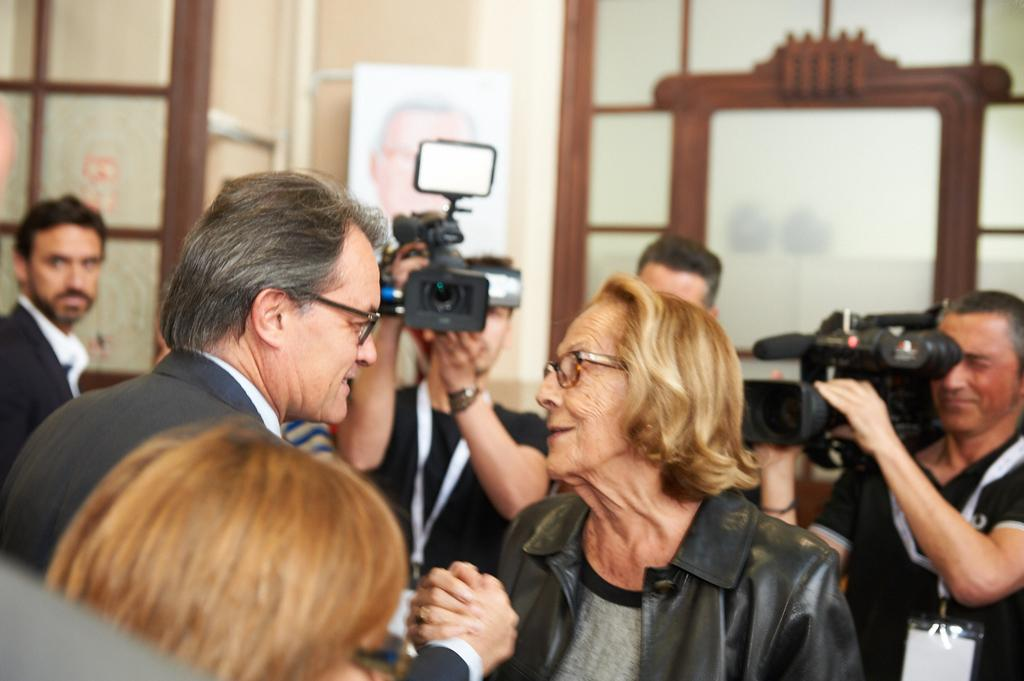How many people are present in the image? There are two people, a man and a woman, present in the image. What are the man and woman doing in the image? The man and woman are holding hands in the image. What can be seen in the background of the image? There are 2 cameramen and 2 men in the background of the image. What type of crown is the man wearing in the image? There is no crown present in the image; the man is not wearing any headgear. How do the acoustics of the room affect the conversation between the man and woman in the image? The provided facts do not mention any information about the acoustics of the room, so it cannot be determined how they might affect the conversation. 